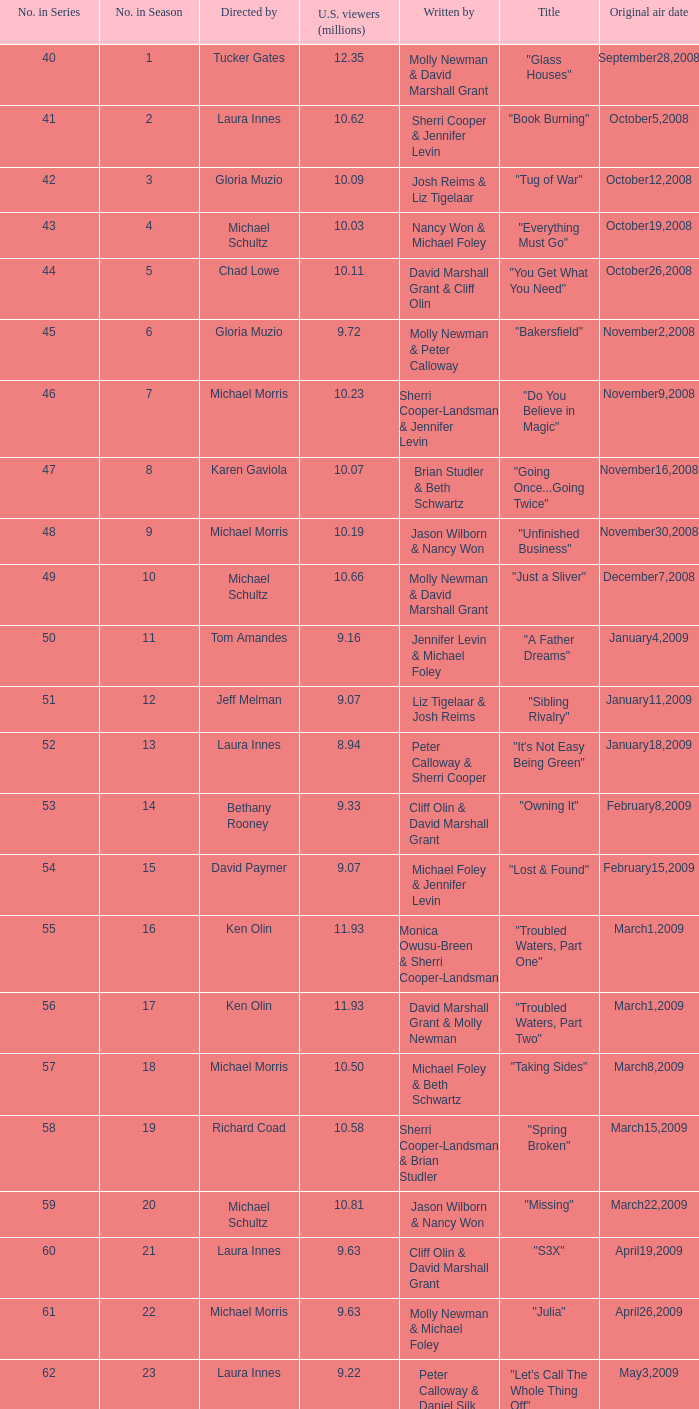When did the episode viewed by 10.50 millions of people in the US run for the first time? March8,2009. Would you mind parsing the complete table? {'header': ['No. in Series', 'No. in Season', 'Directed by', 'U.S. viewers (millions)', 'Written by', 'Title', 'Original air date'], 'rows': [['40', '1', 'Tucker Gates', '12.35', 'Molly Newman & David Marshall Grant', '"Glass Houses"', 'September28,2008'], ['41', '2', 'Laura Innes', '10.62', 'Sherri Cooper & Jennifer Levin', '"Book Burning"', 'October5,2008'], ['42', '3', 'Gloria Muzio', '10.09', 'Josh Reims & Liz Tigelaar', '"Tug of War"', 'October12,2008'], ['43', '4', 'Michael Schultz', '10.03', 'Nancy Won & Michael Foley', '"Everything Must Go"', 'October19,2008'], ['44', '5', 'Chad Lowe', '10.11', 'David Marshall Grant & Cliff Olin', '"You Get What You Need"', 'October26,2008'], ['45', '6', 'Gloria Muzio', '9.72', 'Molly Newman & Peter Calloway', '"Bakersfield"', 'November2,2008'], ['46', '7', 'Michael Morris', '10.23', 'Sherri Cooper-Landsman & Jennifer Levin', '"Do You Believe in Magic"', 'November9,2008'], ['47', '8', 'Karen Gaviola', '10.07', 'Brian Studler & Beth Schwartz', '"Going Once...Going Twice"', 'November16,2008'], ['48', '9', 'Michael Morris', '10.19', 'Jason Wilborn & Nancy Won', '"Unfinished Business"', 'November30,2008'], ['49', '10', 'Michael Schultz', '10.66', 'Molly Newman & David Marshall Grant', '"Just a Sliver"', 'December7,2008'], ['50', '11', 'Tom Amandes', '9.16', 'Jennifer Levin & Michael Foley', '"A Father Dreams"', 'January4,2009'], ['51', '12', 'Jeff Melman', '9.07', 'Liz Tigelaar & Josh Reims', '"Sibling Rivalry"', 'January11,2009'], ['52', '13', 'Laura Innes', '8.94', 'Peter Calloway & Sherri Cooper', '"It\'s Not Easy Being Green"', 'January18,2009'], ['53', '14', 'Bethany Rooney', '9.33', 'Cliff Olin & David Marshall Grant', '"Owning It"', 'February8,2009'], ['54', '15', 'David Paymer', '9.07', 'Michael Foley & Jennifer Levin', '"Lost & Found"', 'February15,2009'], ['55', '16', 'Ken Olin', '11.93', 'Monica Owusu-Breen & Sherri Cooper-Landsman', '"Troubled Waters, Part One"', 'March1,2009'], ['56', '17', 'Ken Olin', '11.93', 'David Marshall Grant & Molly Newman', '"Troubled Waters, Part Two"', 'March1,2009'], ['57', '18', 'Michael Morris', '10.50', 'Michael Foley & Beth Schwartz', '"Taking Sides"', 'March8,2009'], ['58', '19', 'Richard Coad', '10.58', 'Sherri Cooper-Landsman & Brian Studler', '"Spring Broken"', 'March15,2009'], ['59', '20', 'Michael Schultz', '10.81', 'Jason Wilborn & Nancy Won', '"Missing"', 'March22,2009'], ['60', '21', 'Laura Innes', '9.63', 'Cliff Olin & David Marshall Grant', '"S3X"', 'April19,2009'], ['61', '22', 'Michael Morris', '9.63', 'Molly Newman & Michael Foley', '"Julia"', 'April26,2009'], ['62', '23', 'Laura Innes', '9.22', 'Peter Calloway & Daniel Silk', '"Let\'s Call The Whole Thing Off"', 'May3,2009']]} 